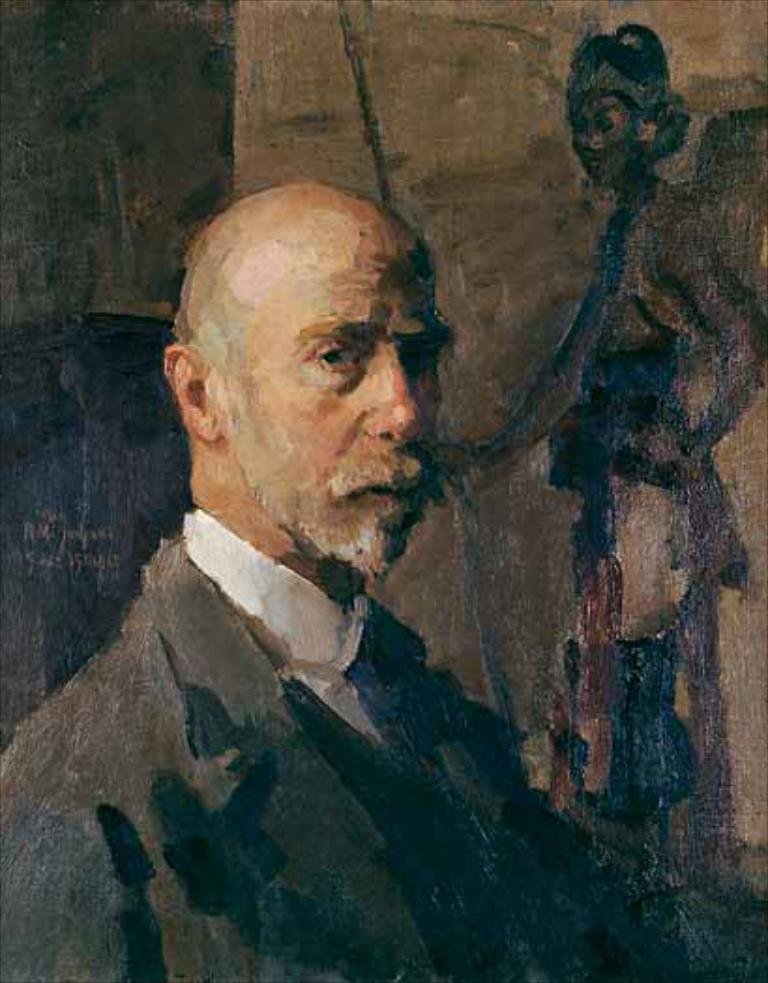What is the main subject of the image? There is a man in the image. Can you describe the background of the image? There is a painting on a wall in the background of the image. What type of credit card does the man have in his hand in the image? There is no credit card visible in the image; the man's hands are not shown. 